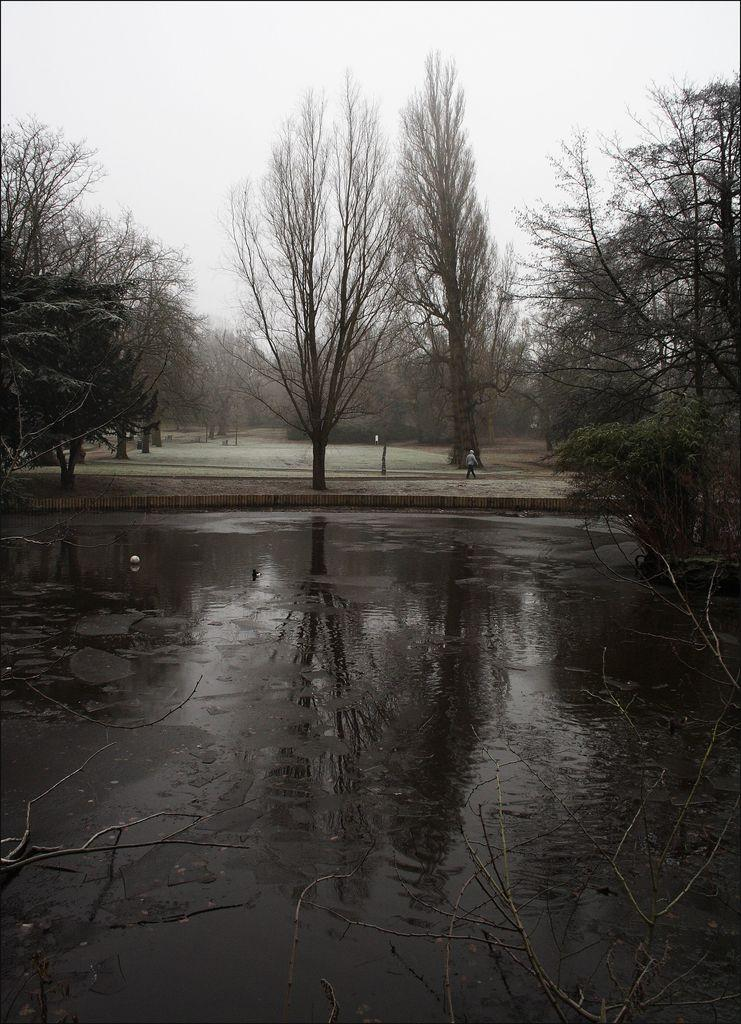What can be seen in the sky in the image? The sky is visible in the image. What type of vegetation is present in the image? There are trees in the image. Can you describe the person in the image? There is a person in the image. What is the water visible in the image? There is water visible in the image. Can you tell me how many snakes are slithering through the water in the image? There are no snakes present in the image; it only features the sky, trees, person, and water. What type of mountain can be seen in the background of the image? There is no mountain visible in the image; it only features the sky, trees, person, and water. 